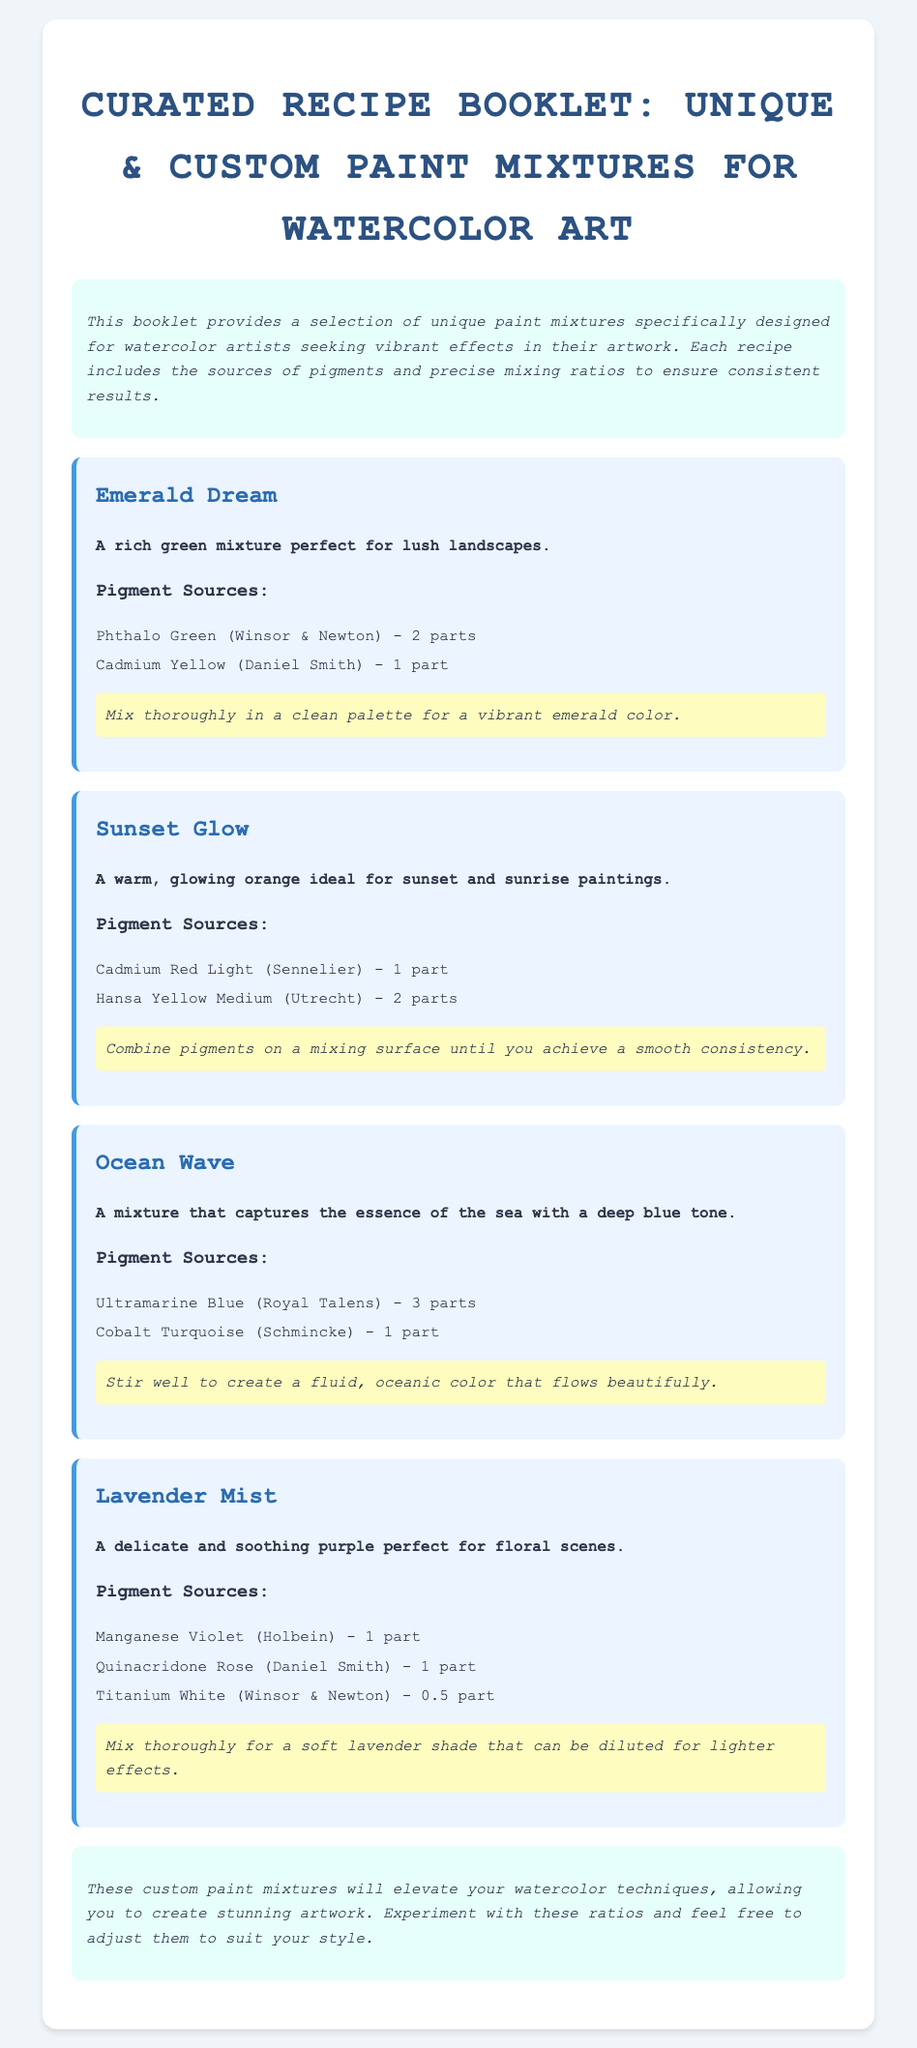What is the title of the booklet? The title of the booklet is presented in the header of the document, indicating its purpose and content.
Answer: Curated Recipe Booklet: Unique & Custom Paint Mixtures for Watercolor Art What is the first recipe listed? The recipes are organized in the order they appear, with the first one being named in the document.
Answer: Emerald Dream How many parts of Phthalo Green are used in the Emerald Dream recipe? The number of parts for each pigment source in the Emerald Dream recipe can be found in its ingredient list.
Answer: 2 parts What pigment source is included in the Sunset Glow recipe? The ingredients for the Sunset Glow recipe specifically list the pigment sources used in the mixture.
Answer: Cadmium Red Light (Sennelier) Which color does the Ocean Wave mixture capture? The description of the Ocean Wave recipe indicates what it aims to represent in color and theme.
Answer: Deep blue tone What is the mixing ratio of Titanium White in the Lavender Mist recipe? The specific ratio for each ingredient, including Titanium White, is detailed in the Lavender Mist recipe.
Answer: 0.5 part How many total pigment sources are listed for the Lavender Mist recipe? The document provides a list of ingredients for the Lavender Mist recipe, which can be counted for a total.
Answer: 3 sources What is the overall purpose of this booklet? The introduction summarizes the primary goal of the booklet regarding its content and target audience.
Answer: To provide a selection of unique paint mixtures for watercolor artists seeking vibrant effects 